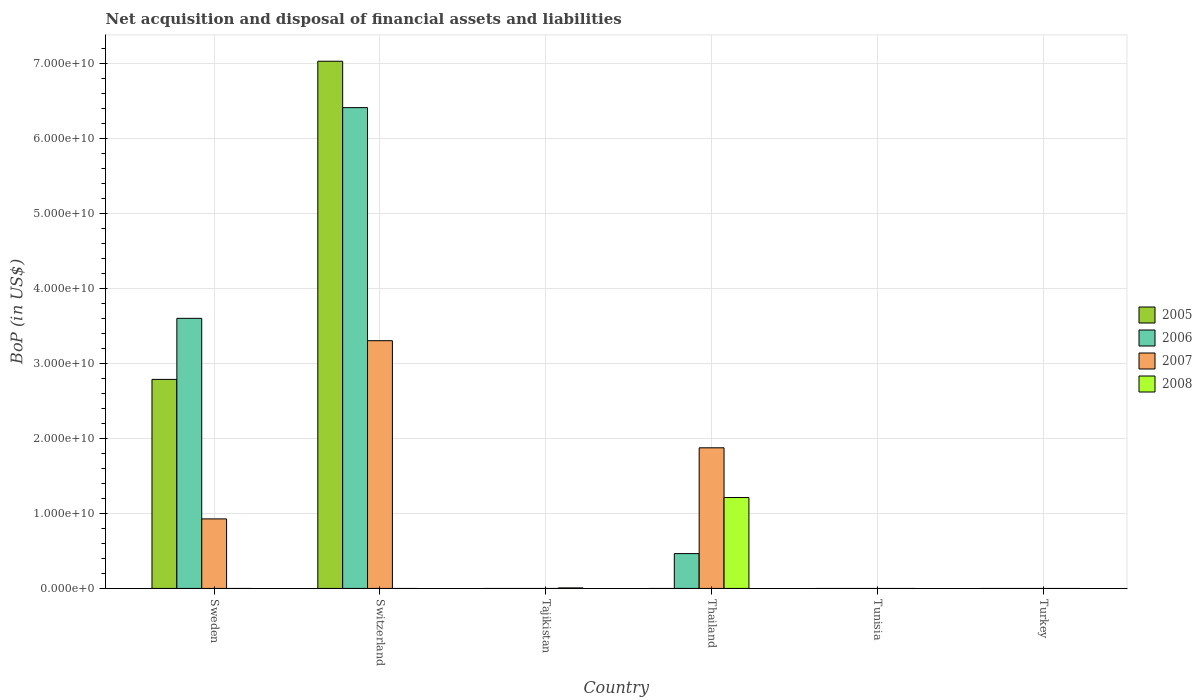Are the number of bars per tick equal to the number of legend labels?
Give a very brief answer. No. Are the number of bars on each tick of the X-axis equal?
Ensure brevity in your answer.  No. How many bars are there on the 2nd tick from the right?
Offer a terse response. 0. What is the label of the 6th group of bars from the left?
Offer a terse response. Turkey. In how many cases, is the number of bars for a given country not equal to the number of legend labels?
Provide a succinct answer. 6. What is the Balance of Payments in 2008 in Sweden?
Give a very brief answer. 0. Across all countries, what is the maximum Balance of Payments in 2007?
Provide a short and direct response. 3.30e+1. Across all countries, what is the minimum Balance of Payments in 2008?
Provide a short and direct response. 0. In which country was the Balance of Payments in 2007 maximum?
Offer a very short reply. Switzerland. What is the total Balance of Payments in 2005 in the graph?
Make the answer very short. 9.81e+1. What is the difference between the Balance of Payments in 2007 in Sweden and that in Switzerland?
Provide a short and direct response. -2.38e+1. What is the difference between the Balance of Payments in 2005 in Thailand and the Balance of Payments in 2007 in Switzerland?
Provide a short and direct response. -3.30e+1. What is the average Balance of Payments in 2007 per country?
Provide a succinct answer. 1.02e+1. What is the difference between the Balance of Payments of/in 2005 and Balance of Payments of/in 2007 in Sweden?
Offer a very short reply. 1.86e+1. What is the ratio of the Balance of Payments in 2007 in Sweden to that in Thailand?
Make the answer very short. 0.49. What is the difference between the highest and the second highest Balance of Payments in 2007?
Offer a very short reply. -1.43e+1. What is the difference between the highest and the lowest Balance of Payments in 2006?
Make the answer very short. 6.41e+1. Is the sum of the Balance of Payments in 2006 in Sweden and Thailand greater than the maximum Balance of Payments in 2007 across all countries?
Offer a very short reply. Yes. Is it the case that in every country, the sum of the Balance of Payments in 2007 and Balance of Payments in 2008 is greater than the sum of Balance of Payments in 2006 and Balance of Payments in 2005?
Offer a very short reply. No. What is the difference between two consecutive major ticks on the Y-axis?
Provide a succinct answer. 1.00e+1. Are the values on the major ticks of Y-axis written in scientific E-notation?
Offer a very short reply. Yes. Does the graph contain any zero values?
Keep it short and to the point. Yes. How many legend labels are there?
Offer a terse response. 4. What is the title of the graph?
Keep it short and to the point. Net acquisition and disposal of financial assets and liabilities. Does "1973" appear as one of the legend labels in the graph?
Your answer should be very brief. No. What is the label or title of the Y-axis?
Provide a short and direct response. BoP (in US$). What is the BoP (in US$) in 2005 in Sweden?
Provide a succinct answer. 2.79e+1. What is the BoP (in US$) in 2006 in Sweden?
Provide a short and direct response. 3.60e+1. What is the BoP (in US$) in 2007 in Sweden?
Keep it short and to the point. 9.27e+09. What is the BoP (in US$) of 2005 in Switzerland?
Your response must be concise. 7.03e+1. What is the BoP (in US$) of 2006 in Switzerland?
Your answer should be very brief. 6.41e+1. What is the BoP (in US$) in 2007 in Switzerland?
Make the answer very short. 3.30e+1. What is the BoP (in US$) in 2008 in Switzerland?
Your answer should be compact. 0. What is the BoP (in US$) in 2005 in Tajikistan?
Your response must be concise. 0. What is the BoP (in US$) in 2006 in Tajikistan?
Give a very brief answer. 0. What is the BoP (in US$) of 2008 in Tajikistan?
Your response must be concise. 6.87e+07. What is the BoP (in US$) in 2005 in Thailand?
Provide a short and direct response. 0. What is the BoP (in US$) of 2006 in Thailand?
Keep it short and to the point. 4.64e+09. What is the BoP (in US$) in 2007 in Thailand?
Your answer should be compact. 1.87e+1. What is the BoP (in US$) of 2008 in Thailand?
Make the answer very short. 1.21e+1. What is the BoP (in US$) of 2005 in Tunisia?
Make the answer very short. 0. What is the BoP (in US$) in 2008 in Tunisia?
Offer a very short reply. 0. What is the BoP (in US$) in 2005 in Turkey?
Your answer should be very brief. 0. What is the BoP (in US$) of 2006 in Turkey?
Keep it short and to the point. 0. Across all countries, what is the maximum BoP (in US$) of 2005?
Ensure brevity in your answer.  7.03e+1. Across all countries, what is the maximum BoP (in US$) of 2006?
Provide a short and direct response. 6.41e+1. Across all countries, what is the maximum BoP (in US$) of 2007?
Ensure brevity in your answer.  3.30e+1. Across all countries, what is the maximum BoP (in US$) of 2008?
Your answer should be very brief. 1.21e+1. Across all countries, what is the minimum BoP (in US$) in 2005?
Ensure brevity in your answer.  0. Across all countries, what is the minimum BoP (in US$) of 2006?
Provide a short and direct response. 0. What is the total BoP (in US$) of 2005 in the graph?
Provide a succinct answer. 9.81e+1. What is the total BoP (in US$) of 2006 in the graph?
Make the answer very short. 1.05e+11. What is the total BoP (in US$) in 2007 in the graph?
Your response must be concise. 6.10e+1. What is the total BoP (in US$) in 2008 in the graph?
Provide a succinct answer. 1.22e+1. What is the difference between the BoP (in US$) of 2005 in Sweden and that in Switzerland?
Give a very brief answer. -4.24e+1. What is the difference between the BoP (in US$) in 2006 in Sweden and that in Switzerland?
Your answer should be compact. -2.81e+1. What is the difference between the BoP (in US$) in 2007 in Sweden and that in Switzerland?
Your answer should be compact. -2.38e+1. What is the difference between the BoP (in US$) of 2006 in Sweden and that in Thailand?
Give a very brief answer. 3.14e+1. What is the difference between the BoP (in US$) of 2007 in Sweden and that in Thailand?
Make the answer very short. -9.48e+09. What is the difference between the BoP (in US$) of 2006 in Switzerland and that in Thailand?
Keep it short and to the point. 5.95e+1. What is the difference between the BoP (in US$) in 2007 in Switzerland and that in Thailand?
Your answer should be very brief. 1.43e+1. What is the difference between the BoP (in US$) in 2008 in Tajikistan and that in Thailand?
Ensure brevity in your answer.  -1.21e+1. What is the difference between the BoP (in US$) in 2005 in Sweden and the BoP (in US$) in 2006 in Switzerland?
Keep it short and to the point. -3.62e+1. What is the difference between the BoP (in US$) in 2005 in Sweden and the BoP (in US$) in 2007 in Switzerland?
Your answer should be compact. -5.16e+09. What is the difference between the BoP (in US$) of 2006 in Sweden and the BoP (in US$) of 2007 in Switzerland?
Your answer should be very brief. 2.98e+09. What is the difference between the BoP (in US$) in 2005 in Sweden and the BoP (in US$) in 2008 in Tajikistan?
Provide a short and direct response. 2.78e+1. What is the difference between the BoP (in US$) in 2006 in Sweden and the BoP (in US$) in 2008 in Tajikistan?
Offer a terse response. 3.59e+1. What is the difference between the BoP (in US$) of 2007 in Sweden and the BoP (in US$) of 2008 in Tajikistan?
Provide a succinct answer. 9.20e+09. What is the difference between the BoP (in US$) in 2005 in Sweden and the BoP (in US$) in 2006 in Thailand?
Make the answer very short. 2.32e+1. What is the difference between the BoP (in US$) in 2005 in Sweden and the BoP (in US$) in 2007 in Thailand?
Ensure brevity in your answer.  9.12e+09. What is the difference between the BoP (in US$) of 2005 in Sweden and the BoP (in US$) of 2008 in Thailand?
Keep it short and to the point. 1.57e+1. What is the difference between the BoP (in US$) in 2006 in Sweden and the BoP (in US$) in 2007 in Thailand?
Your answer should be compact. 1.73e+1. What is the difference between the BoP (in US$) of 2006 in Sweden and the BoP (in US$) of 2008 in Thailand?
Provide a succinct answer. 2.39e+1. What is the difference between the BoP (in US$) of 2007 in Sweden and the BoP (in US$) of 2008 in Thailand?
Your answer should be compact. -2.85e+09. What is the difference between the BoP (in US$) of 2005 in Switzerland and the BoP (in US$) of 2008 in Tajikistan?
Provide a short and direct response. 7.02e+1. What is the difference between the BoP (in US$) of 2006 in Switzerland and the BoP (in US$) of 2008 in Tajikistan?
Give a very brief answer. 6.40e+1. What is the difference between the BoP (in US$) of 2007 in Switzerland and the BoP (in US$) of 2008 in Tajikistan?
Offer a terse response. 3.30e+1. What is the difference between the BoP (in US$) in 2005 in Switzerland and the BoP (in US$) in 2006 in Thailand?
Your answer should be very brief. 6.56e+1. What is the difference between the BoP (in US$) in 2005 in Switzerland and the BoP (in US$) in 2007 in Thailand?
Offer a terse response. 5.15e+1. What is the difference between the BoP (in US$) of 2005 in Switzerland and the BoP (in US$) of 2008 in Thailand?
Give a very brief answer. 5.82e+1. What is the difference between the BoP (in US$) of 2006 in Switzerland and the BoP (in US$) of 2007 in Thailand?
Give a very brief answer. 4.53e+1. What is the difference between the BoP (in US$) in 2006 in Switzerland and the BoP (in US$) in 2008 in Thailand?
Your answer should be very brief. 5.20e+1. What is the difference between the BoP (in US$) in 2007 in Switzerland and the BoP (in US$) in 2008 in Thailand?
Keep it short and to the point. 2.09e+1. What is the average BoP (in US$) in 2005 per country?
Provide a succinct answer. 1.64e+1. What is the average BoP (in US$) of 2006 per country?
Give a very brief answer. 1.75e+1. What is the average BoP (in US$) in 2007 per country?
Provide a succinct answer. 1.02e+1. What is the average BoP (in US$) in 2008 per country?
Provide a succinct answer. 2.03e+09. What is the difference between the BoP (in US$) in 2005 and BoP (in US$) in 2006 in Sweden?
Make the answer very short. -8.14e+09. What is the difference between the BoP (in US$) in 2005 and BoP (in US$) in 2007 in Sweden?
Offer a terse response. 1.86e+1. What is the difference between the BoP (in US$) in 2006 and BoP (in US$) in 2007 in Sweden?
Ensure brevity in your answer.  2.67e+1. What is the difference between the BoP (in US$) of 2005 and BoP (in US$) of 2006 in Switzerland?
Make the answer very short. 6.18e+09. What is the difference between the BoP (in US$) in 2005 and BoP (in US$) in 2007 in Switzerland?
Provide a short and direct response. 3.73e+1. What is the difference between the BoP (in US$) of 2006 and BoP (in US$) of 2007 in Switzerland?
Make the answer very short. 3.11e+1. What is the difference between the BoP (in US$) in 2006 and BoP (in US$) in 2007 in Thailand?
Offer a terse response. -1.41e+1. What is the difference between the BoP (in US$) of 2006 and BoP (in US$) of 2008 in Thailand?
Make the answer very short. -7.48e+09. What is the difference between the BoP (in US$) in 2007 and BoP (in US$) in 2008 in Thailand?
Give a very brief answer. 6.63e+09. What is the ratio of the BoP (in US$) of 2005 in Sweden to that in Switzerland?
Your response must be concise. 0.4. What is the ratio of the BoP (in US$) in 2006 in Sweden to that in Switzerland?
Give a very brief answer. 0.56. What is the ratio of the BoP (in US$) of 2007 in Sweden to that in Switzerland?
Your answer should be compact. 0.28. What is the ratio of the BoP (in US$) in 2006 in Sweden to that in Thailand?
Your response must be concise. 7.75. What is the ratio of the BoP (in US$) of 2007 in Sweden to that in Thailand?
Keep it short and to the point. 0.49. What is the ratio of the BoP (in US$) in 2006 in Switzerland to that in Thailand?
Give a very brief answer. 13.8. What is the ratio of the BoP (in US$) of 2007 in Switzerland to that in Thailand?
Give a very brief answer. 1.76. What is the ratio of the BoP (in US$) of 2008 in Tajikistan to that in Thailand?
Your answer should be compact. 0.01. What is the difference between the highest and the second highest BoP (in US$) of 2006?
Make the answer very short. 2.81e+1. What is the difference between the highest and the second highest BoP (in US$) in 2007?
Provide a short and direct response. 1.43e+1. What is the difference between the highest and the lowest BoP (in US$) in 2005?
Your answer should be compact. 7.03e+1. What is the difference between the highest and the lowest BoP (in US$) of 2006?
Your answer should be very brief. 6.41e+1. What is the difference between the highest and the lowest BoP (in US$) in 2007?
Ensure brevity in your answer.  3.30e+1. What is the difference between the highest and the lowest BoP (in US$) of 2008?
Offer a terse response. 1.21e+1. 